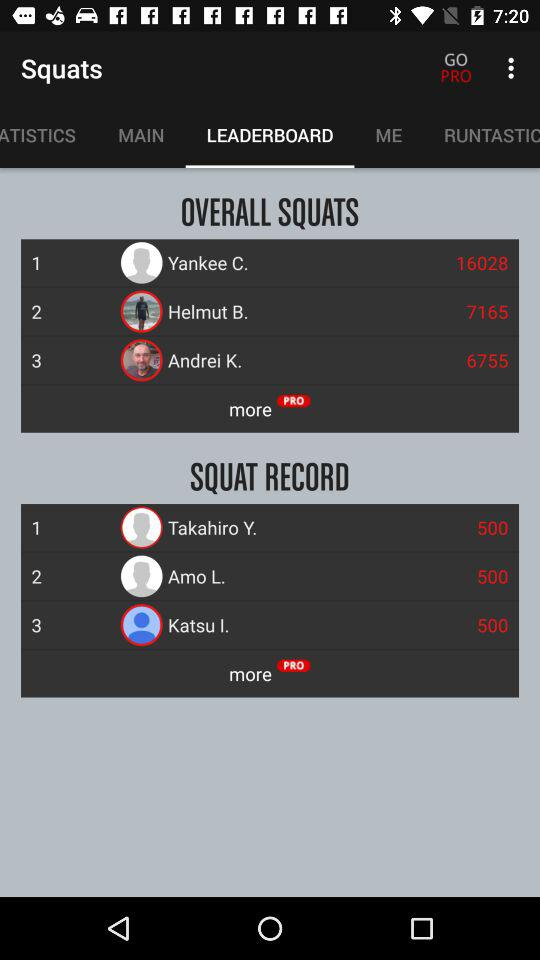What is the squat record of Amo L.? The squat record is 500. 